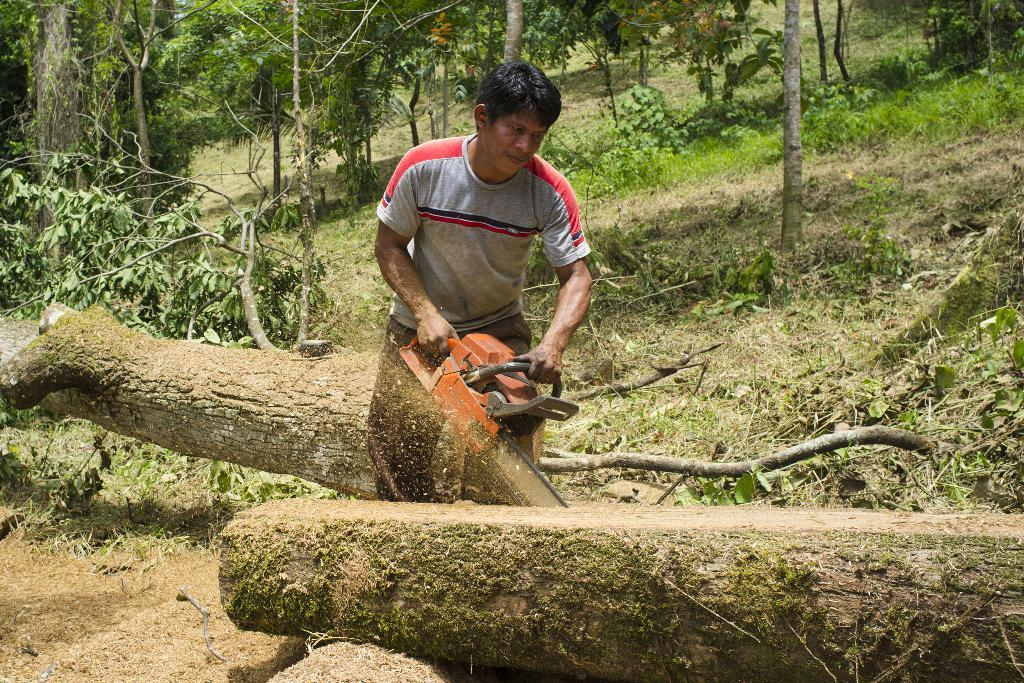Who is the main subject in the image? There is a man in the image. What is the man doing in the image? The man is cutting a tree. What tool is the man using to cut the tree? The man is using a machine to cut the tree. What can be seen in the background of the image? There are many trees in the background of the image. What type of police action is taking place in the image? There is no police action present in the image; it features a man cutting a tree with a machine. Who is the owner of the trees in the image? The image does not provide information about the ownership of the trees. 